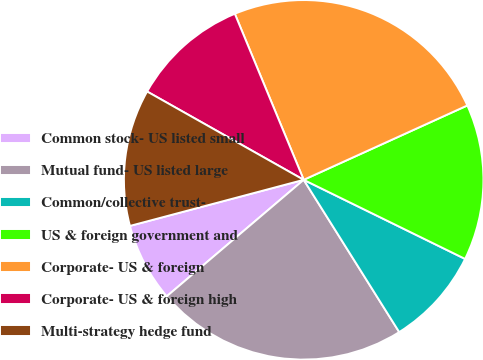<chart> <loc_0><loc_0><loc_500><loc_500><pie_chart><fcel>Common stock- US listed small<fcel>Mutual fund- US listed large<fcel>Common/collective trust-<fcel>US & foreign government and<fcel>Corporate- US & foreign<fcel>Corporate- US & foreign high<fcel>Multi-strategy hedge fund<nl><fcel>7.09%<fcel>22.7%<fcel>8.83%<fcel>14.04%<fcel>24.47%<fcel>10.57%<fcel>12.3%<nl></chart> 